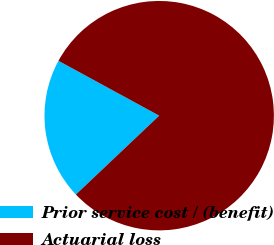<chart> <loc_0><loc_0><loc_500><loc_500><pie_chart><fcel>Prior service cost / (benefit)<fcel>Actuarial loss<nl><fcel>20.0%<fcel>80.0%<nl></chart> 